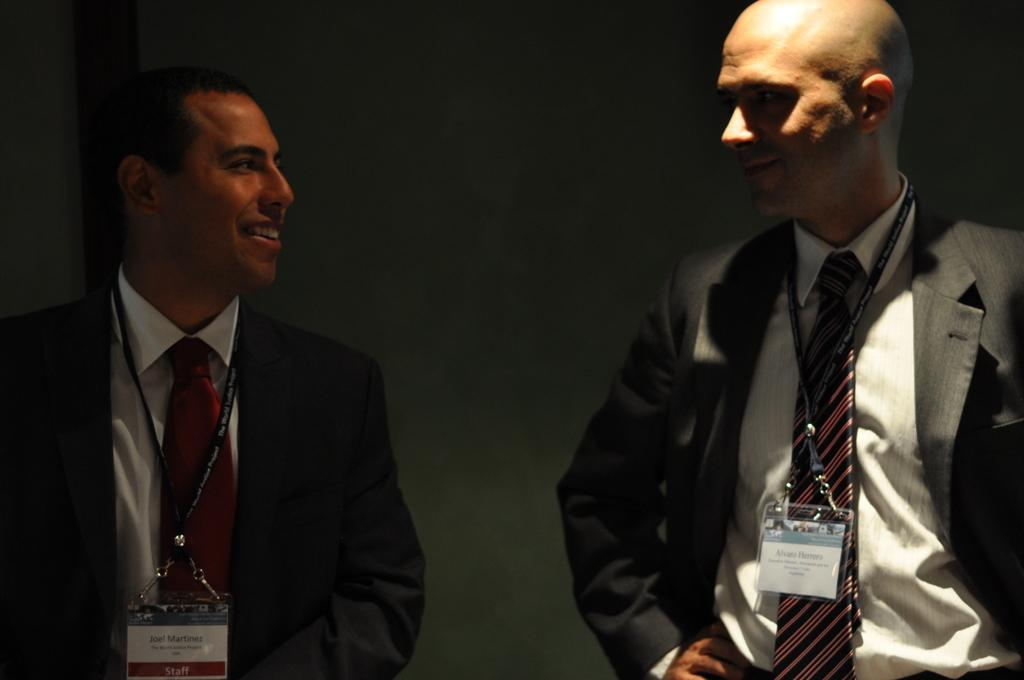How many people are in the image? There are two men in the image. What are the men doing in the image? The men are standing together. What type of clothing are the men wearing? The men are wearing blazers. What can be seen on the men's clothing? The men have tags on their clothing. What type of limit can be seen in the image? There is no limit present in the image. How many boys are in the image? The image does not show any boys; it features two men. 